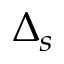<formula> <loc_0><loc_0><loc_500><loc_500>\Delta _ { s }</formula> 